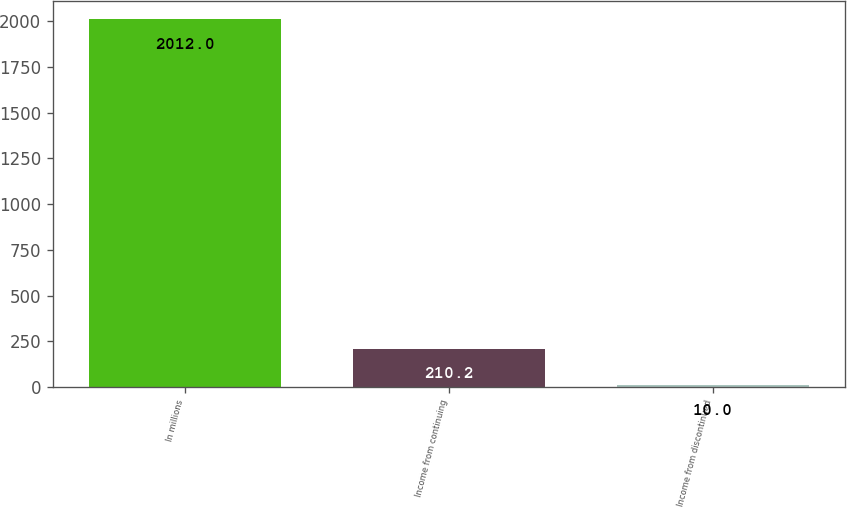Convert chart to OTSL. <chart><loc_0><loc_0><loc_500><loc_500><bar_chart><fcel>In millions<fcel>Income from continuing<fcel>Income from discontinued<nl><fcel>2012<fcel>210.2<fcel>10<nl></chart> 